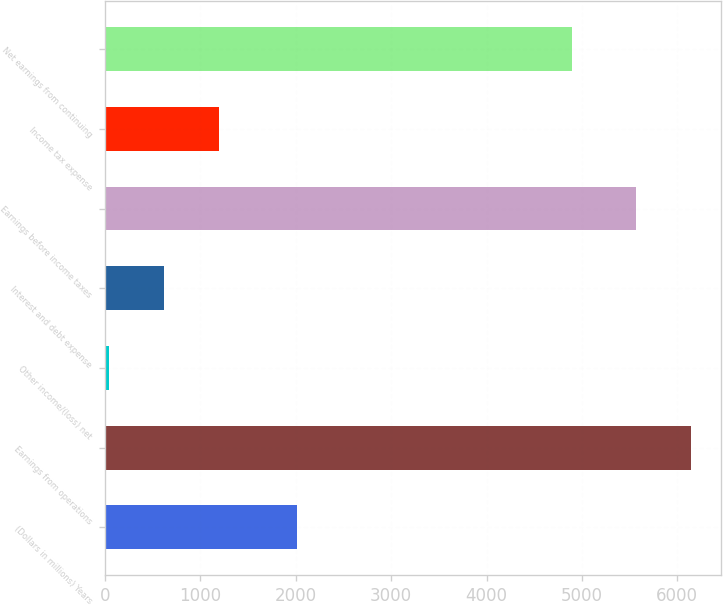Convert chart. <chart><loc_0><loc_0><loc_500><loc_500><bar_chart><fcel>(Dollars in millions) Years<fcel>Earnings from operations<fcel>Other income/(loss) net<fcel>Interest and debt expense<fcel>Earnings before income taxes<fcel>Income tax expense<fcel>Net earnings from continuing<nl><fcel>2016<fcel>6147.4<fcel>40<fcel>619.4<fcel>5568<fcel>1198.8<fcel>4895<nl></chart> 